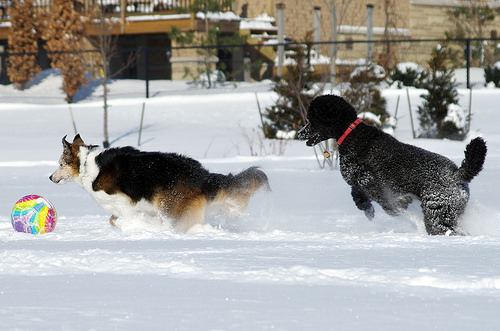<image>
Can you confirm if the ball is in front of the dog? Yes. The ball is positioned in front of the dog, appearing closer to the camera viewpoint. 